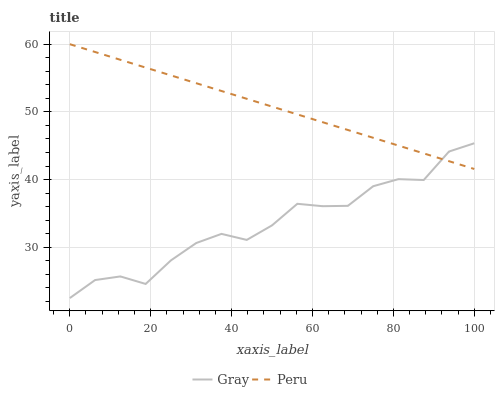Does Gray have the minimum area under the curve?
Answer yes or no. Yes. Does Peru have the maximum area under the curve?
Answer yes or no. Yes. Does Peru have the minimum area under the curve?
Answer yes or no. No. Is Peru the smoothest?
Answer yes or no. Yes. Is Gray the roughest?
Answer yes or no. Yes. Is Peru the roughest?
Answer yes or no. No. Does Peru have the lowest value?
Answer yes or no. No. Does Peru have the highest value?
Answer yes or no. Yes. Does Gray intersect Peru?
Answer yes or no. Yes. Is Gray less than Peru?
Answer yes or no. No. Is Gray greater than Peru?
Answer yes or no. No. 